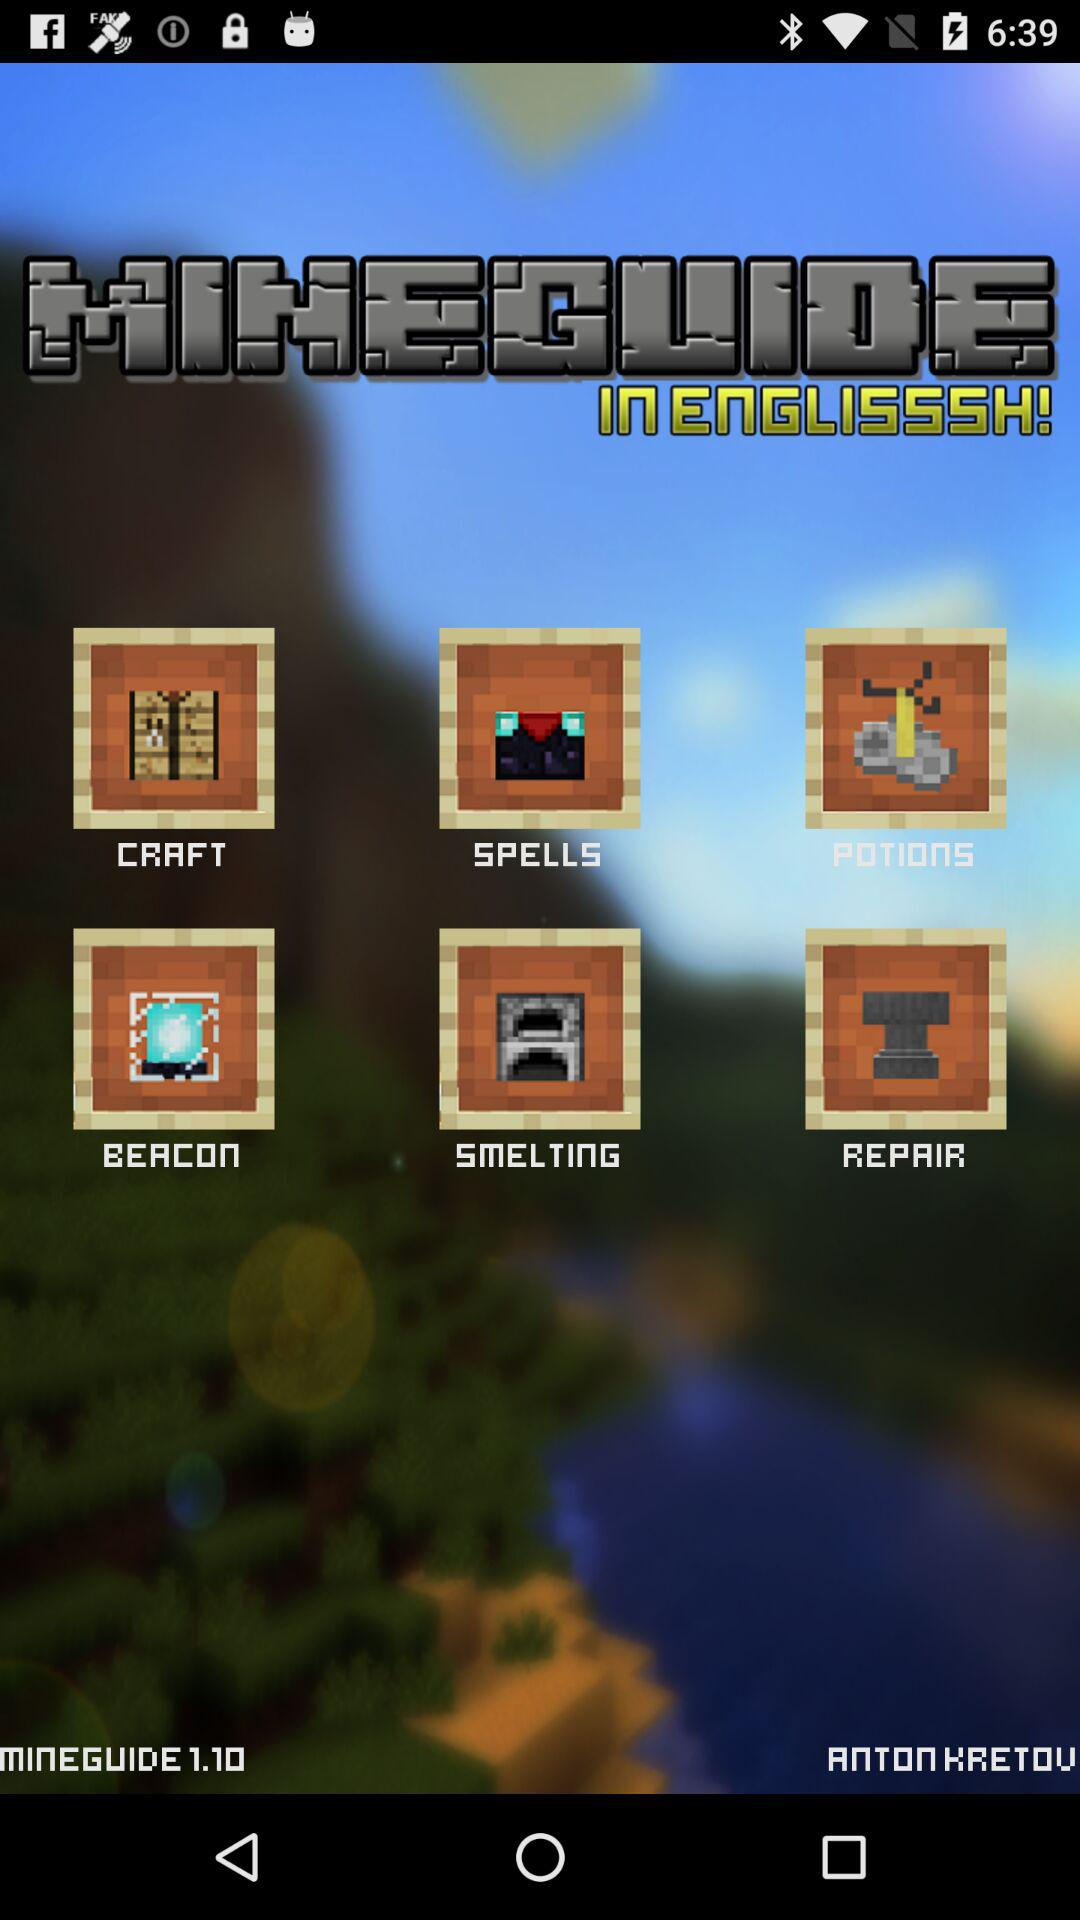How many items are in the second row?
Answer the question using a single word or phrase. 3 